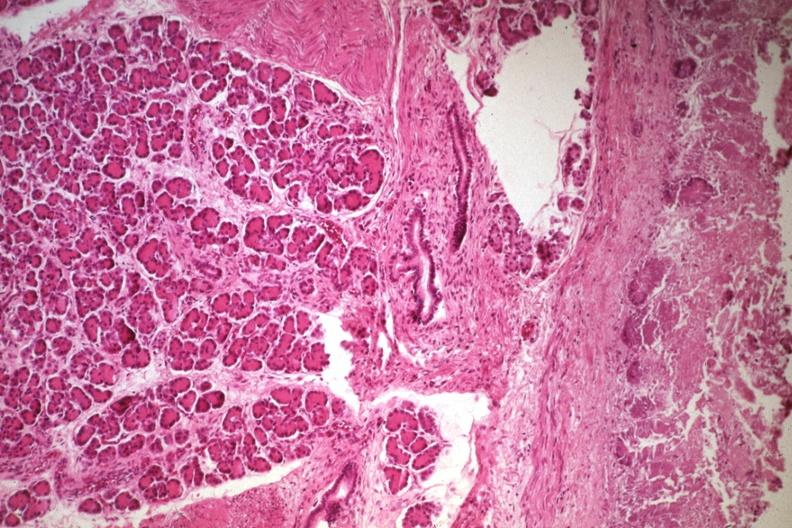does cranial artery show not the best photo but a good illustration of lesion?
Answer the question using a single word or phrase. No 